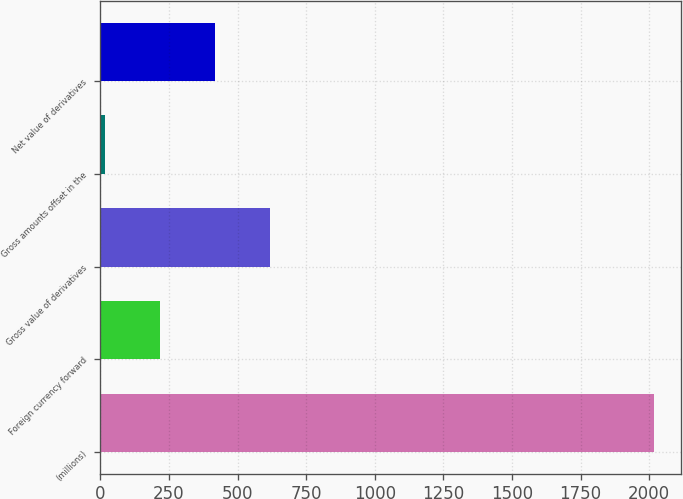Convert chart. <chart><loc_0><loc_0><loc_500><loc_500><bar_chart><fcel>(millions)<fcel>Foreign currency forward<fcel>Gross value of derivatives<fcel>Gross amounts offset in the<fcel>Net value of derivatives<nl><fcel>2017<fcel>217<fcel>617<fcel>17<fcel>417<nl></chart> 